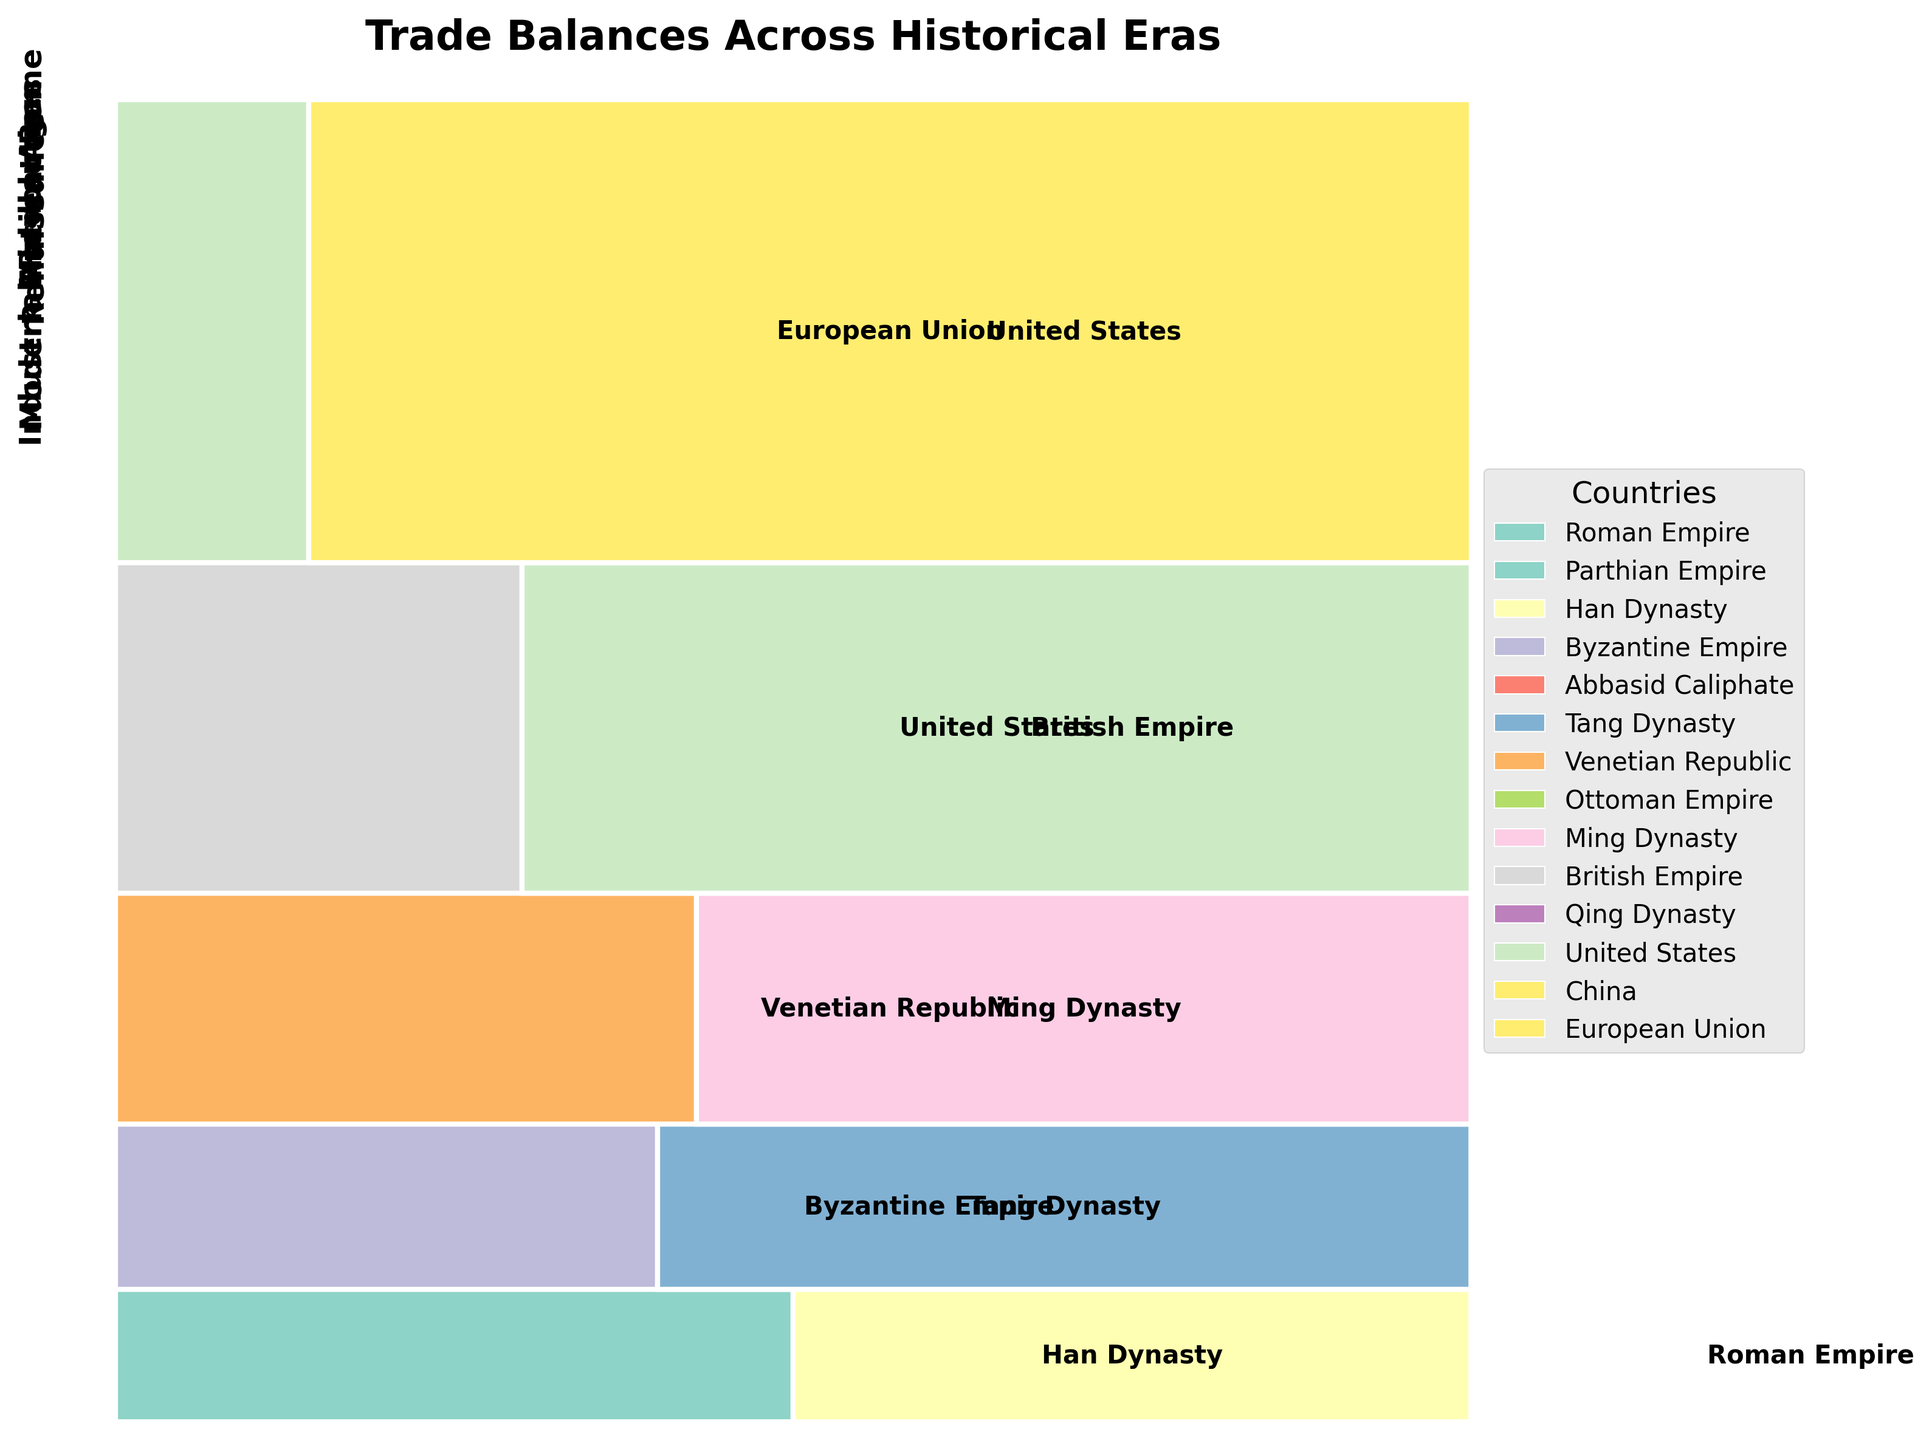How many countries are represented in the Modern Era? Count the number of distinct countries in the Modern Era section of the plot.
Answer: 3 What is the trade balance status for the Ottoman Empire during the Renaissance? Look at the Renaissance section and identify the color corresponding to the Ottoman Empire; then check if it is in the surplus or deficit area.
Answer: Deficit Which era had the largest overall trade balance surplus? Compare the relative size of the surplus sections across all eras and identify the one with the largest.
Answer: Modern Era Which country had a deficit in the Industrial Revolution? Identify the specific country label within the Industrial Revolution era; the deficit country will use a different color and the label positioning might vary.
Answer: Qing Dynasty What is the total trade balance for the Roman Empire and Han Dynasty during Ancient Rome? Identify the areas corresponding to the Roman Empire and Han Dynasty in Ancient Rome, sum their trade balance values (1000 + 200).
Answer: 1200 Is the United States represented in more than one era? Look for the label "United States" in different sections of the plot and count the occurrences.
Answer: Yes Which era has more countries with surplus trade balances compared to deficits? Count the number of countries with surplus versus deficit trade balances in each era and compare these counts for each era.
Answer: Modern Era What are the significant differences in trade balances between the British Empire and the Qing Dynasty during the Industrial Revolution? Identify and compare the sizes and labels of the British Empire and Qing Dynasty trade balances within the Industrial Revolution section, noting the trade balance and status.
Answer: British Empire has a surplus of 1500, Qing Dynasty has a deficit of 1200 